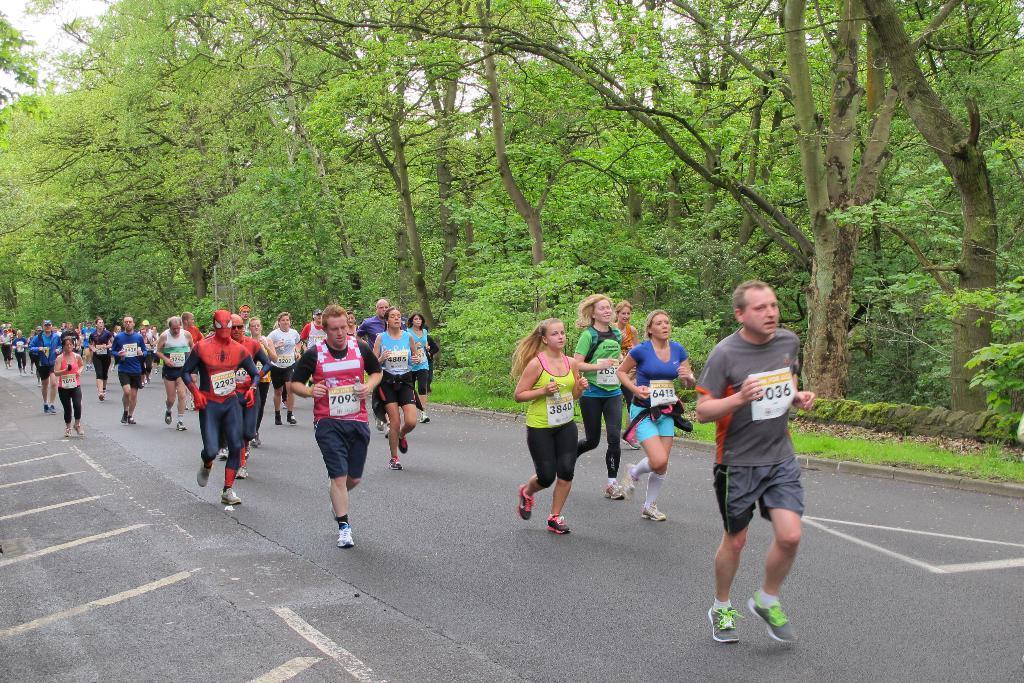Can you describe this image briefly? In this picture we can see so many people are running on the road, side we can see some trees and grass. 